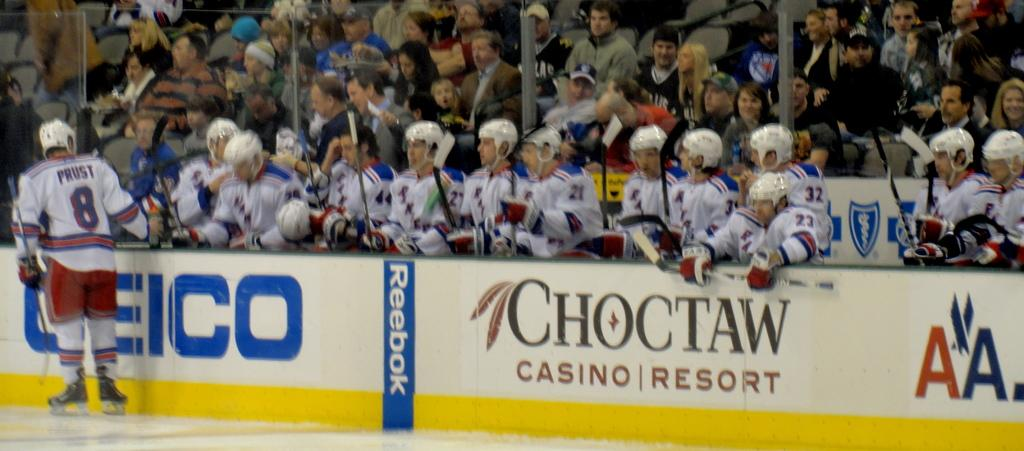<image>
Describe the image concisely. the word Choctaw is on the white wall 